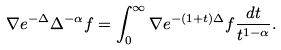Convert formula to latex. <formula><loc_0><loc_0><loc_500><loc_500>\nabla e ^ { - \Delta } \Delta ^ { - \alpha } f = \int _ { 0 } ^ { \infty } \nabla e ^ { - ( 1 + t ) \Delta } f \frac { d t } { t ^ { 1 - \alpha } } .</formula> 